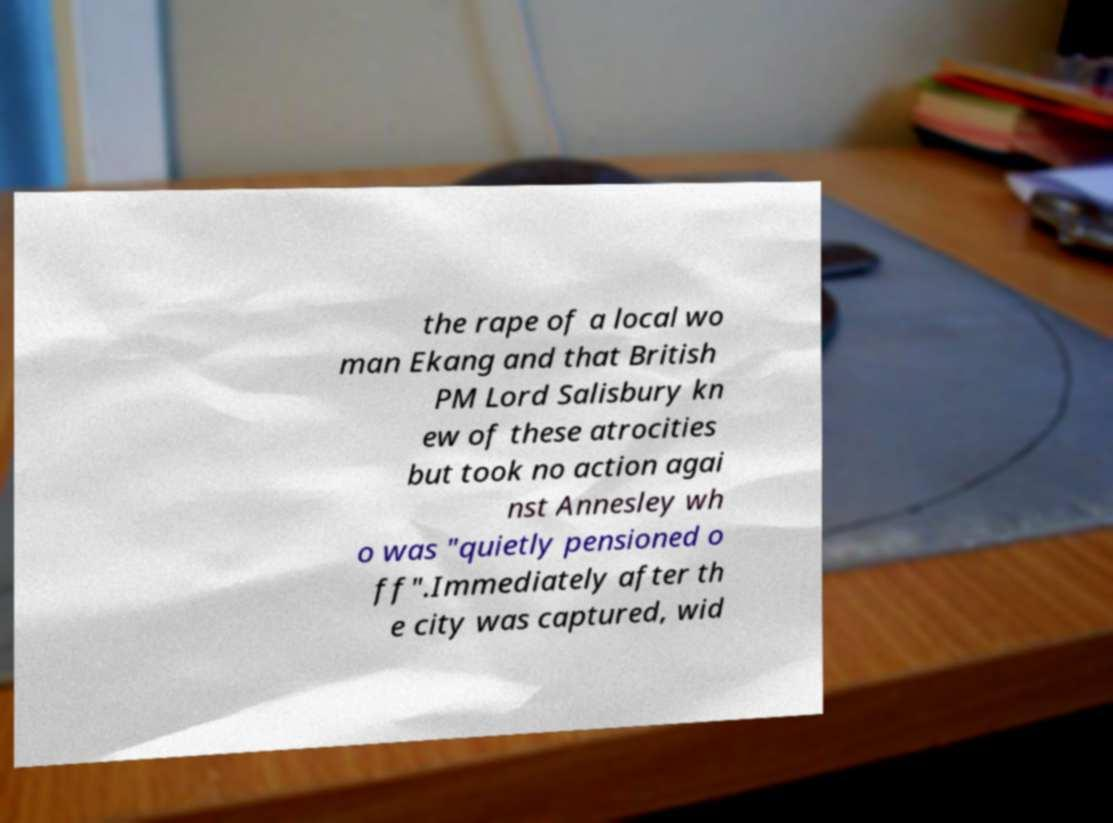Please identify and transcribe the text found in this image. the rape of a local wo man Ekang and that British PM Lord Salisbury kn ew of these atrocities but took no action agai nst Annesley wh o was "quietly pensioned o ff".Immediately after th e city was captured, wid 